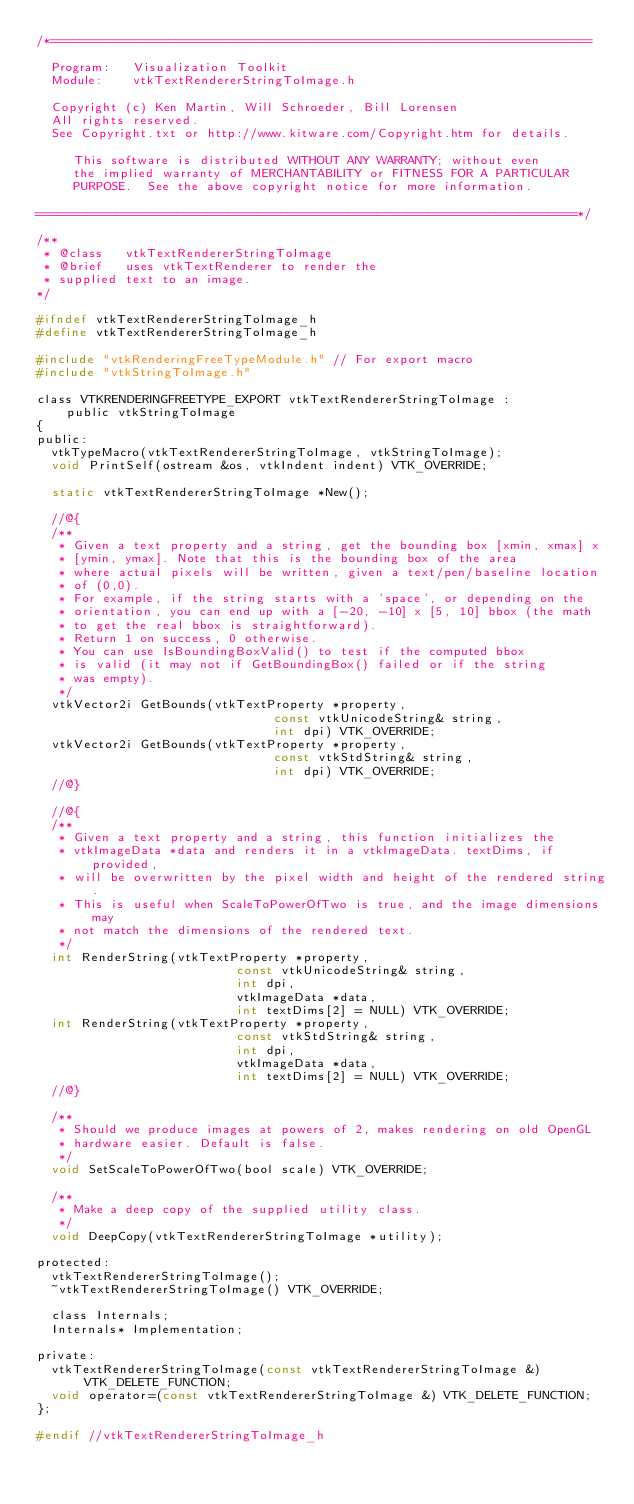Convert code to text. <code><loc_0><loc_0><loc_500><loc_500><_C_>/*=========================================================================

  Program:   Visualization Toolkit
  Module:    vtkTextRendererStringToImage.h

  Copyright (c) Ken Martin, Will Schroeder, Bill Lorensen
  All rights reserved.
  See Copyright.txt or http://www.kitware.com/Copyright.htm for details.

     This software is distributed WITHOUT ANY WARRANTY; without even
     the implied warranty of MERCHANTABILITY or FITNESS FOR A PARTICULAR
     PURPOSE.  See the above copyright notice for more information.

=========================================================================*/

/**
 * @class   vtkTextRendererStringToImage
 * @brief   uses vtkTextRenderer to render the
 * supplied text to an image.
*/

#ifndef vtkTextRendererStringToImage_h
#define vtkTextRendererStringToImage_h

#include "vtkRenderingFreeTypeModule.h" // For export macro
#include "vtkStringToImage.h"

class VTKRENDERINGFREETYPE_EXPORT vtkTextRendererStringToImage :
    public vtkStringToImage
{
public:
  vtkTypeMacro(vtkTextRendererStringToImage, vtkStringToImage);
  void PrintSelf(ostream &os, vtkIndent indent) VTK_OVERRIDE;

  static vtkTextRendererStringToImage *New();

  //@{
  /**
   * Given a text property and a string, get the bounding box [xmin, xmax] x
   * [ymin, ymax]. Note that this is the bounding box of the area
   * where actual pixels will be written, given a text/pen/baseline location
   * of (0,0).
   * For example, if the string starts with a 'space', or depending on the
   * orientation, you can end up with a [-20, -10] x [5, 10] bbox (the math
   * to get the real bbox is straightforward).
   * Return 1 on success, 0 otherwise.
   * You can use IsBoundingBoxValid() to test if the computed bbox
   * is valid (it may not if GetBoundingBox() failed or if the string
   * was empty).
   */
  vtkVector2i GetBounds(vtkTextProperty *property,
                                const vtkUnicodeString& string,
                                int dpi) VTK_OVERRIDE;
  vtkVector2i GetBounds(vtkTextProperty *property,
                                const vtkStdString& string,
                                int dpi) VTK_OVERRIDE;
  //@}

  //@{
  /**
   * Given a text property and a string, this function initializes the
   * vtkImageData *data and renders it in a vtkImageData. textDims, if provided,
   * will be overwritten by the pixel width and height of the rendered string.
   * This is useful when ScaleToPowerOfTwo is true, and the image dimensions may
   * not match the dimensions of the rendered text.
   */
  int RenderString(vtkTextProperty *property,
                           const vtkUnicodeString& string,
                           int dpi,
                           vtkImageData *data,
                           int textDims[2] = NULL) VTK_OVERRIDE;
  int RenderString(vtkTextProperty *property,
                           const vtkStdString& string,
                           int dpi,
                           vtkImageData *data,
                           int textDims[2] = NULL) VTK_OVERRIDE;
  //@}

  /**
   * Should we produce images at powers of 2, makes rendering on old OpenGL
   * hardware easier. Default is false.
   */
  void SetScaleToPowerOfTwo(bool scale) VTK_OVERRIDE;

  /**
   * Make a deep copy of the supplied utility class.
   */
  void DeepCopy(vtkTextRendererStringToImage *utility);

protected:
  vtkTextRendererStringToImage();
  ~vtkTextRendererStringToImage() VTK_OVERRIDE;

  class Internals;
  Internals* Implementation;

private:
  vtkTextRendererStringToImage(const vtkTextRendererStringToImage &) VTK_DELETE_FUNCTION;
  void operator=(const vtkTextRendererStringToImage &) VTK_DELETE_FUNCTION;
};

#endif //vtkTextRendererStringToImage_h
</code> 